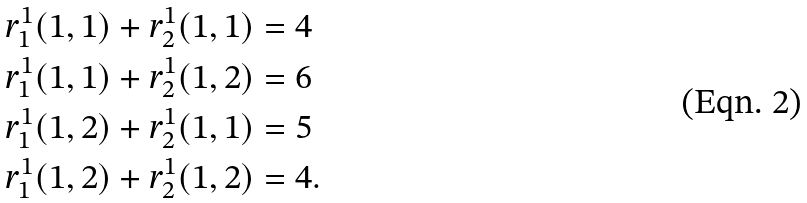Convert formula to latex. <formula><loc_0><loc_0><loc_500><loc_500>& r ^ { 1 } _ { 1 } ( 1 , 1 ) + r _ { 2 } ^ { 1 } ( 1 , 1 ) = 4 \\ & r ^ { 1 } _ { 1 } ( 1 , 1 ) + r _ { 2 } ^ { 1 } ( 1 , 2 ) = 6 \\ & r ^ { 1 } _ { 1 } ( 1 , 2 ) + r _ { 2 } ^ { 1 } ( 1 , 1 ) = 5 \\ & r ^ { 1 } _ { 1 } ( 1 , 2 ) + r _ { 2 } ^ { 1 } ( 1 , 2 ) = 4 .</formula> 